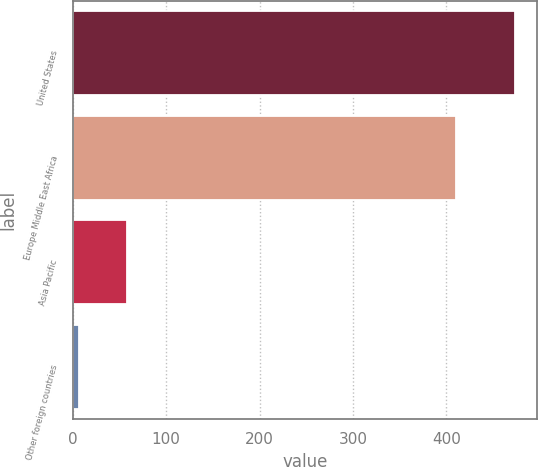Convert chart to OTSL. <chart><loc_0><loc_0><loc_500><loc_500><bar_chart><fcel>United States<fcel>Europe Middle East Africa<fcel>Asia Pacific<fcel>Other foreign countries<nl><fcel>473<fcel>410<fcel>58<fcel>7<nl></chart> 